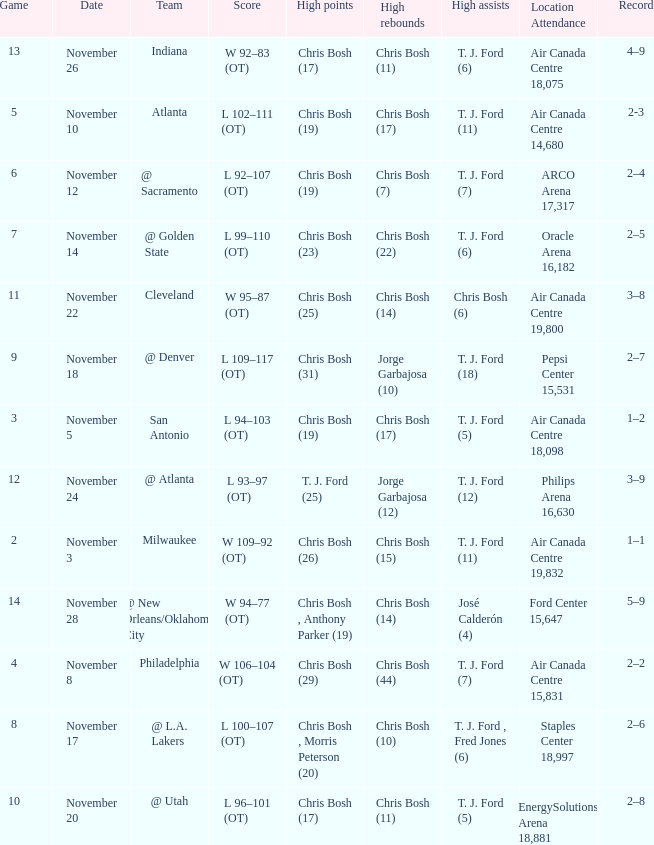What was the score of the game on November 12? L 92–107 (OT). 